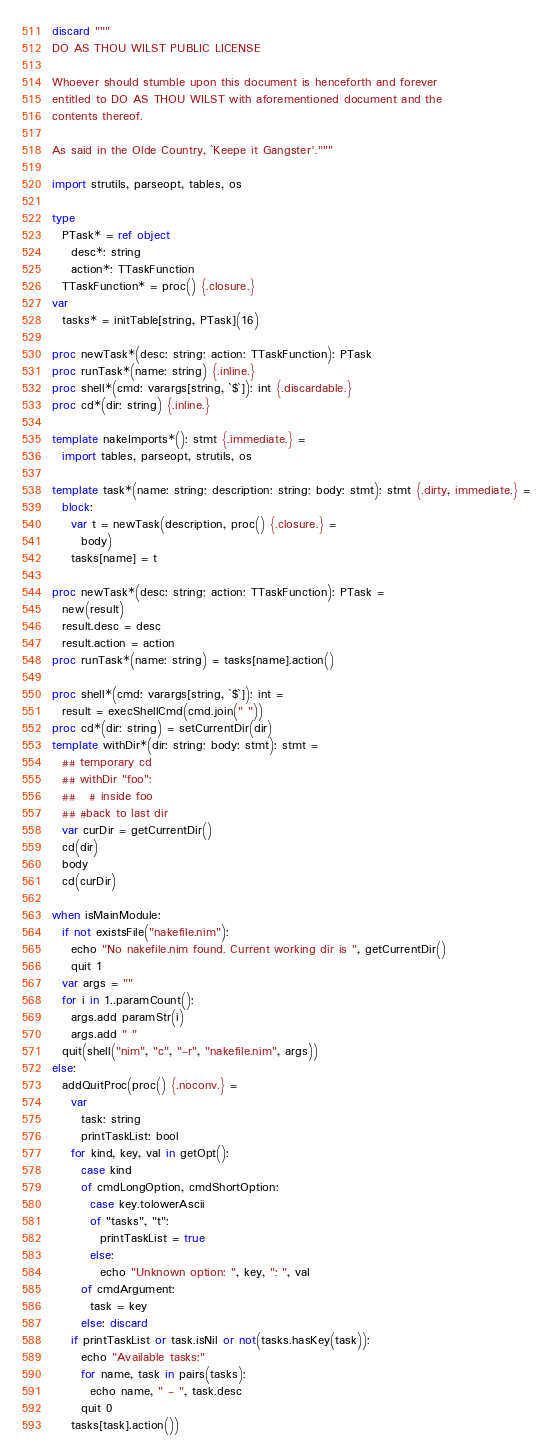<code> <loc_0><loc_0><loc_500><loc_500><_Nim_>discard """
DO AS THOU WILST PUBLIC LICENSE

Whoever should stumble upon this document is henceforth and forever
entitled to DO AS THOU WILST with aforementioned document and the
contents thereof.

As said in the Olde Country, `Keepe it Gangster'."""

import strutils, parseopt, tables, os

type
  PTask* = ref object
    desc*: string
    action*: TTaskFunction
  TTaskFunction* = proc() {.closure.}
var
  tasks* = initTable[string, PTask](16)

proc newTask*(desc: string; action: TTaskFunction): PTask
proc runTask*(name: string) {.inline.}
proc shell*(cmd: varargs[string, `$`]): int {.discardable.}
proc cd*(dir: string) {.inline.}

template nakeImports*(): stmt {.immediate.} =
  import tables, parseopt, strutils, os

template task*(name: string; description: string; body: stmt): stmt {.dirty, immediate.} =
  block:
    var t = newTask(description, proc() {.closure.} =
      body)
    tasks[name] = t

proc newTask*(desc: string; action: TTaskFunction): PTask =
  new(result)
  result.desc = desc
  result.action = action
proc runTask*(name: string) = tasks[name].action()

proc shell*(cmd: varargs[string, `$`]): int =
  result = execShellCmd(cmd.join(" "))
proc cd*(dir: string) = setCurrentDir(dir)
template withDir*(dir: string; body: stmt): stmt =
  ## temporary cd
  ## withDir "foo":
  ##   # inside foo
  ## #back to last dir
  var curDir = getCurrentDir()
  cd(dir)
  body
  cd(curDir)

when isMainModule:
  if not existsFile("nakefile.nim"):
    echo "No nakefile.nim found. Current working dir is ", getCurrentDir()
    quit 1
  var args = ""
  for i in 1..paramCount():
    args.add paramStr(i)
    args.add " "
  quit(shell("nim", "c", "-r", "nakefile.nim", args))
else:
  addQuitProc(proc() {.noconv.} =
    var
      task: string
      printTaskList: bool
    for kind, key, val in getOpt():
      case kind
      of cmdLongOption, cmdShortOption:
        case key.tolowerAscii
        of "tasks", "t":
          printTaskList = true
        else:
          echo "Unknown option: ", key, ": ", val
      of cmdArgument:
        task = key
      else: discard
    if printTaskList or task.isNil or not(tasks.hasKey(task)):
      echo "Available tasks:"
      for name, task in pairs(tasks):
        echo name, " - ", task.desc
      quit 0
    tasks[task].action())
</code> 